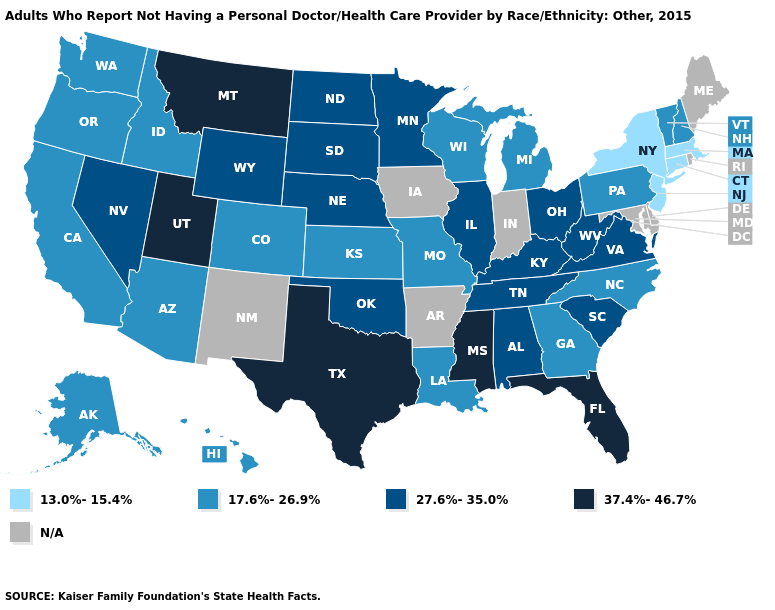Which states hav the highest value in the Northeast?
Concise answer only. New Hampshire, Pennsylvania, Vermont. Is the legend a continuous bar?
Give a very brief answer. No. What is the value of Arizona?
Short answer required. 17.6%-26.9%. Is the legend a continuous bar?
Answer briefly. No. Among the states that border Indiana , which have the highest value?
Write a very short answer. Illinois, Kentucky, Ohio. Name the states that have a value in the range 27.6%-35.0%?
Answer briefly. Alabama, Illinois, Kentucky, Minnesota, Nebraska, Nevada, North Dakota, Ohio, Oklahoma, South Carolina, South Dakota, Tennessee, Virginia, West Virginia, Wyoming. Name the states that have a value in the range 37.4%-46.7%?
Short answer required. Florida, Mississippi, Montana, Texas, Utah. Which states have the highest value in the USA?
Concise answer only. Florida, Mississippi, Montana, Texas, Utah. Name the states that have a value in the range 27.6%-35.0%?
Short answer required. Alabama, Illinois, Kentucky, Minnesota, Nebraska, Nevada, North Dakota, Ohio, Oklahoma, South Carolina, South Dakota, Tennessee, Virginia, West Virginia, Wyoming. Is the legend a continuous bar?
Write a very short answer. No. Name the states that have a value in the range 27.6%-35.0%?
Write a very short answer. Alabama, Illinois, Kentucky, Minnesota, Nebraska, Nevada, North Dakota, Ohio, Oklahoma, South Carolina, South Dakota, Tennessee, Virginia, West Virginia, Wyoming. Does the first symbol in the legend represent the smallest category?
Concise answer only. Yes. What is the value of Georgia?
Short answer required. 17.6%-26.9%. How many symbols are there in the legend?
Quick response, please. 5. 